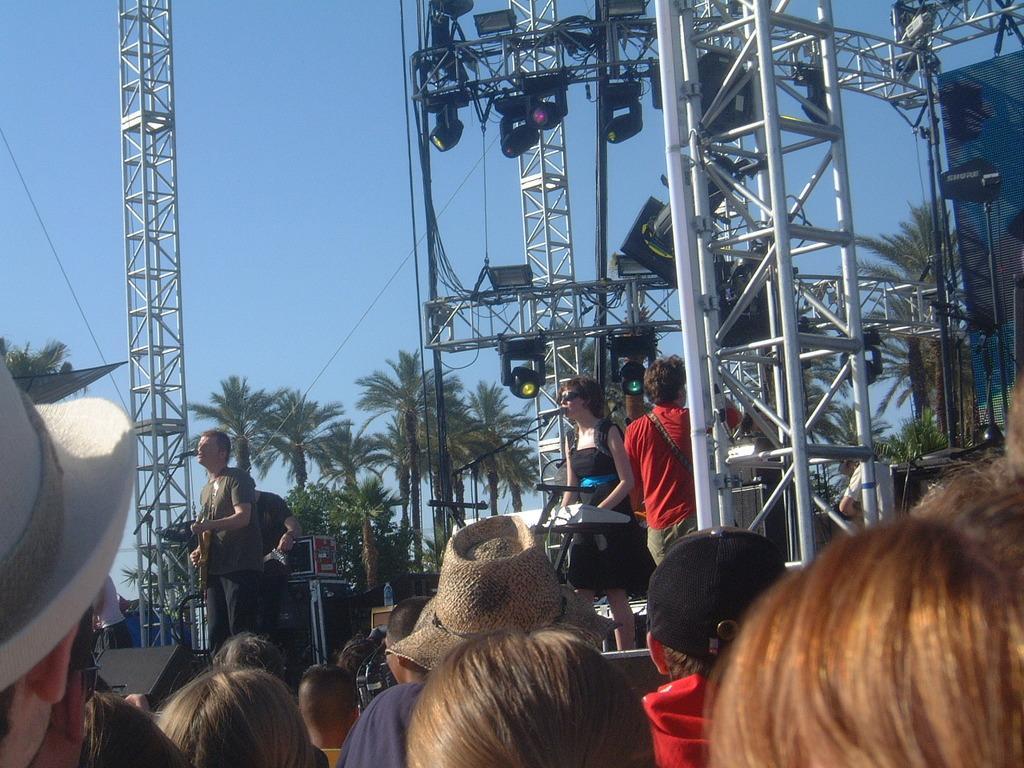Please provide a concise description of this image. In this image I can see heads of number of persons and few of them are wearing hats. In the background I can see few persons standing in front of microphones on the stage and I can see few musical instruments in front of them. I can see few metal poles, few lights, few trees and I can see the sky, few wires and the building in the background. 